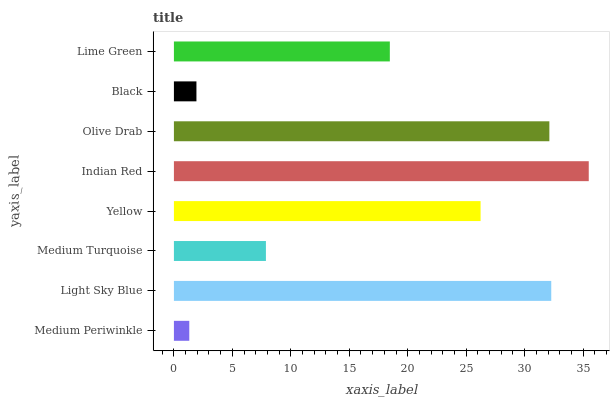Is Medium Periwinkle the minimum?
Answer yes or no. Yes. Is Indian Red the maximum?
Answer yes or no. Yes. Is Light Sky Blue the minimum?
Answer yes or no. No. Is Light Sky Blue the maximum?
Answer yes or no. No. Is Light Sky Blue greater than Medium Periwinkle?
Answer yes or no. Yes. Is Medium Periwinkle less than Light Sky Blue?
Answer yes or no. Yes. Is Medium Periwinkle greater than Light Sky Blue?
Answer yes or no. No. Is Light Sky Blue less than Medium Periwinkle?
Answer yes or no. No. Is Yellow the high median?
Answer yes or no. Yes. Is Lime Green the low median?
Answer yes or no. Yes. Is Lime Green the high median?
Answer yes or no. No. Is Light Sky Blue the low median?
Answer yes or no. No. 